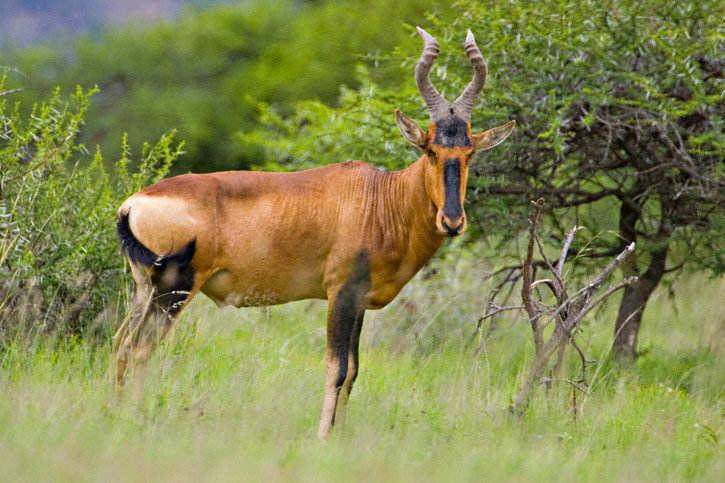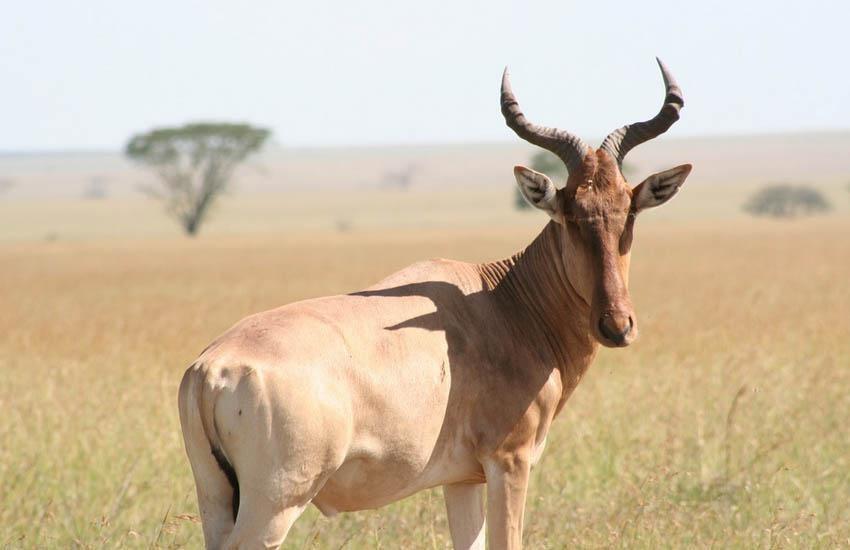The first image is the image on the left, the second image is the image on the right. For the images displayed, is the sentence "The right image shows two antelope in the grass." factually correct? Answer yes or no. No. The first image is the image on the left, the second image is the image on the right. Given the left and right images, does the statement "The right image contains at twice as many horned animals as the left image." hold true? Answer yes or no. No. 